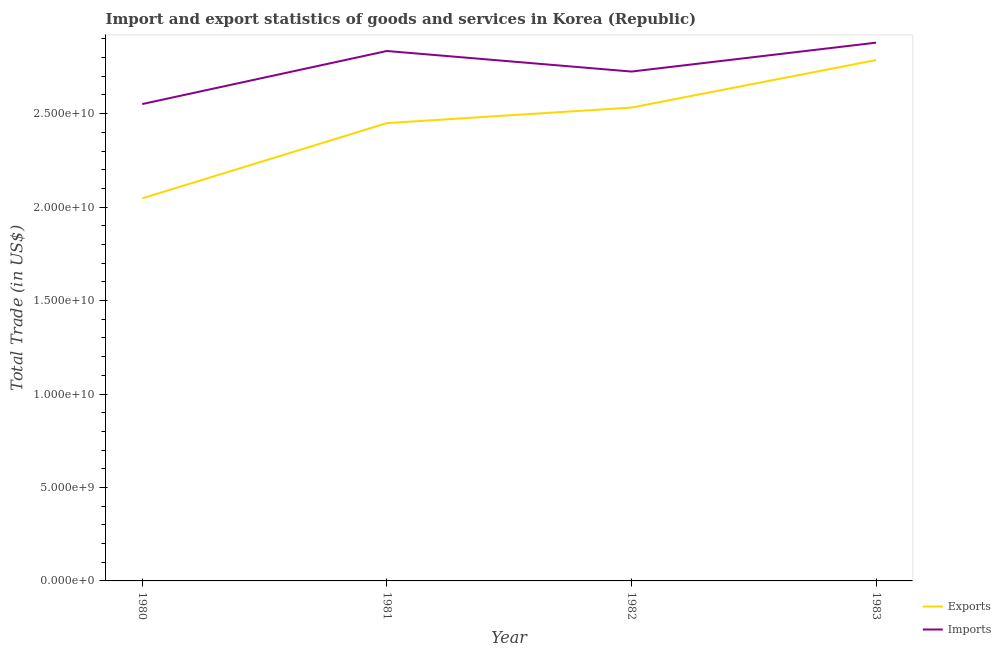What is the imports of goods and services in 1982?
Give a very brief answer. 2.73e+1. Across all years, what is the maximum export of goods and services?
Ensure brevity in your answer.  2.79e+1. Across all years, what is the minimum imports of goods and services?
Give a very brief answer. 2.55e+1. In which year was the export of goods and services maximum?
Give a very brief answer. 1983. What is the total imports of goods and services in the graph?
Your response must be concise. 1.10e+11. What is the difference between the export of goods and services in 1980 and that in 1981?
Your response must be concise. -4.02e+09. What is the difference between the imports of goods and services in 1980 and the export of goods and services in 1983?
Offer a terse response. -2.35e+09. What is the average imports of goods and services per year?
Offer a very short reply. 2.75e+1. In the year 1981, what is the difference between the imports of goods and services and export of goods and services?
Your answer should be very brief. 3.86e+09. What is the ratio of the imports of goods and services in 1981 to that in 1983?
Your response must be concise. 0.98. Is the export of goods and services in 1981 less than that in 1982?
Provide a short and direct response. Yes. What is the difference between the highest and the second highest export of goods and services?
Keep it short and to the point. 2.54e+09. What is the difference between the highest and the lowest export of goods and services?
Offer a very short reply. 7.40e+09. Is the sum of the export of goods and services in 1980 and 1981 greater than the maximum imports of goods and services across all years?
Offer a very short reply. Yes. How many years are there in the graph?
Provide a short and direct response. 4. Does the graph contain any zero values?
Your answer should be compact. No. Does the graph contain grids?
Offer a terse response. No. How many legend labels are there?
Make the answer very short. 2. What is the title of the graph?
Give a very brief answer. Import and export statistics of goods and services in Korea (Republic). What is the label or title of the X-axis?
Provide a short and direct response. Year. What is the label or title of the Y-axis?
Your answer should be compact. Total Trade (in US$). What is the Total Trade (in US$) of Exports in 1980?
Your response must be concise. 2.05e+1. What is the Total Trade (in US$) of Imports in 1980?
Provide a short and direct response. 2.55e+1. What is the Total Trade (in US$) in Exports in 1981?
Your answer should be very brief. 2.45e+1. What is the Total Trade (in US$) in Imports in 1981?
Make the answer very short. 2.84e+1. What is the Total Trade (in US$) in Exports in 1982?
Give a very brief answer. 2.53e+1. What is the Total Trade (in US$) of Imports in 1982?
Ensure brevity in your answer.  2.73e+1. What is the Total Trade (in US$) of Exports in 1983?
Provide a succinct answer. 2.79e+1. What is the Total Trade (in US$) in Imports in 1983?
Your answer should be compact. 2.88e+1. Across all years, what is the maximum Total Trade (in US$) of Exports?
Your response must be concise. 2.79e+1. Across all years, what is the maximum Total Trade (in US$) of Imports?
Your answer should be very brief. 2.88e+1. Across all years, what is the minimum Total Trade (in US$) of Exports?
Your response must be concise. 2.05e+1. Across all years, what is the minimum Total Trade (in US$) in Imports?
Provide a short and direct response. 2.55e+1. What is the total Total Trade (in US$) of Exports in the graph?
Provide a succinct answer. 9.81e+1. What is the total Total Trade (in US$) of Imports in the graph?
Make the answer very short. 1.10e+11. What is the difference between the Total Trade (in US$) of Exports in 1980 and that in 1981?
Offer a very short reply. -4.02e+09. What is the difference between the Total Trade (in US$) in Imports in 1980 and that in 1981?
Your answer should be compact. -2.84e+09. What is the difference between the Total Trade (in US$) of Exports in 1980 and that in 1982?
Provide a short and direct response. -4.86e+09. What is the difference between the Total Trade (in US$) in Imports in 1980 and that in 1982?
Your response must be concise. -1.74e+09. What is the difference between the Total Trade (in US$) in Exports in 1980 and that in 1983?
Your answer should be very brief. -7.40e+09. What is the difference between the Total Trade (in US$) in Imports in 1980 and that in 1983?
Your answer should be very brief. -3.28e+09. What is the difference between the Total Trade (in US$) in Exports in 1981 and that in 1982?
Make the answer very short. -8.33e+08. What is the difference between the Total Trade (in US$) in Imports in 1981 and that in 1982?
Provide a succinct answer. 1.10e+09. What is the difference between the Total Trade (in US$) of Exports in 1981 and that in 1983?
Ensure brevity in your answer.  -3.37e+09. What is the difference between the Total Trade (in US$) of Imports in 1981 and that in 1983?
Give a very brief answer. -4.46e+08. What is the difference between the Total Trade (in US$) of Exports in 1982 and that in 1983?
Keep it short and to the point. -2.54e+09. What is the difference between the Total Trade (in US$) in Imports in 1982 and that in 1983?
Give a very brief answer. -1.55e+09. What is the difference between the Total Trade (in US$) in Exports in 1980 and the Total Trade (in US$) in Imports in 1981?
Give a very brief answer. -7.88e+09. What is the difference between the Total Trade (in US$) in Exports in 1980 and the Total Trade (in US$) in Imports in 1982?
Ensure brevity in your answer.  -6.78e+09. What is the difference between the Total Trade (in US$) in Exports in 1980 and the Total Trade (in US$) in Imports in 1983?
Make the answer very short. -8.33e+09. What is the difference between the Total Trade (in US$) in Exports in 1981 and the Total Trade (in US$) in Imports in 1982?
Provide a short and direct response. -2.76e+09. What is the difference between the Total Trade (in US$) in Exports in 1981 and the Total Trade (in US$) in Imports in 1983?
Provide a short and direct response. -4.30e+09. What is the difference between the Total Trade (in US$) in Exports in 1982 and the Total Trade (in US$) in Imports in 1983?
Offer a terse response. -3.47e+09. What is the average Total Trade (in US$) in Exports per year?
Provide a short and direct response. 2.45e+1. What is the average Total Trade (in US$) of Imports per year?
Make the answer very short. 2.75e+1. In the year 1980, what is the difference between the Total Trade (in US$) of Exports and Total Trade (in US$) of Imports?
Ensure brevity in your answer.  -5.04e+09. In the year 1981, what is the difference between the Total Trade (in US$) in Exports and Total Trade (in US$) in Imports?
Offer a very short reply. -3.86e+09. In the year 1982, what is the difference between the Total Trade (in US$) of Exports and Total Trade (in US$) of Imports?
Give a very brief answer. -1.93e+09. In the year 1983, what is the difference between the Total Trade (in US$) in Exports and Total Trade (in US$) in Imports?
Your answer should be very brief. -9.31e+08. What is the ratio of the Total Trade (in US$) in Exports in 1980 to that in 1981?
Give a very brief answer. 0.84. What is the ratio of the Total Trade (in US$) in Imports in 1980 to that in 1981?
Your answer should be compact. 0.9. What is the ratio of the Total Trade (in US$) of Exports in 1980 to that in 1982?
Your answer should be compact. 0.81. What is the ratio of the Total Trade (in US$) in Imports in 1980 to that in 1982?
Make the answer very short. 0.94. What is the ratio of the Total Trade (in US$) in Exports in 1980 to that in 1983?
Ensure brevity in your answer.  0.73. What is the ratio of the Total Trade (in US$) in Imports in 1980 to that in 1983?
Your answer should be very brief. 0.89. What is the ratio of the Total Trade (in US$) of Exports in 1981 to that in 1982?
Your response must be concise. 0.97. What is the ratio of the Total Trade (in US$) of Imports in 1981 to that in 1982?
Offer a very short reply. 1.04. What is the ratio of the Total Trade (in US$) of Exports in 1981 to that in 1983?
Make the answer very short. 0.88. What is the ratio of the Total Trade (in US$) in Imports in 1981 to that in 1983?
Provide a short and direct response. 0.98. What is the ratio of the Total Trade (in US$) in Exports in 1982 to that in 1983?
Make the answer very short. 0.91. What is the ratio of the Total Trade (in US$) of Imports in 1982 to that in 1983?
Offer a very short reply. 0.95. What is the difference between the highest and the second highest Total Trade (in US$) of Exports?
Provide a short and direct response. 2.54e+09. What is the difference between the highest and the second highest Total Trade (in US$) of Imports?
Make the answer very short. 4.46e+08. What is the difference between the highest and the lowest Total Trade (in US$) of Exports?
Provide a short and direct response. 7.40e+09. What is the difference between the highest and the lowest Total Trade (in US$) of Imports?
Give a very brief answer. 3.28e+09. 